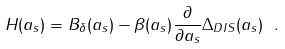Convert formula to latex. <formula><loc_0><loc_0><loc_500><loc_500>H ( a _ { s } ) = B _ { \delta } ( a _ { s } ) - \beta ( a _ { s } ) \frac { \partial } { \partial a _ { s } } \Delta _ { D I S } ( a _ { s } ) \ .</formula> 